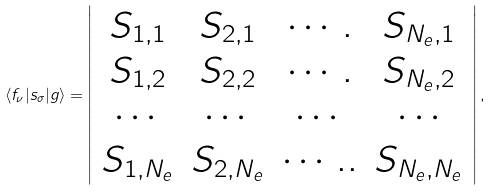Convert formula to latex. <formula><loc_0><loc_0><loc_500><loc_500>\langle f _ { \nu } | s _ { \sigma } | g \rangle = \left | \begin{array} { c c c c } S _ { 1 , 1 } & S _ { 2 , 1 } & \cdots . & S _ { N _ { e } , 1 } \\ S _ { 1 , 2 } & S _ { 2 , 2 } & \cdots . & S _ { N _ { e } , 2 } \\ \cdots & \cdots & \cdots & \cdots \\ S _ { 1 , N _ { e } } & S _ { 2 , N _ { e } } & \cdots . . & S _ { N _ { e } , N _ { e } } \end{array} \right | ,</formula> 